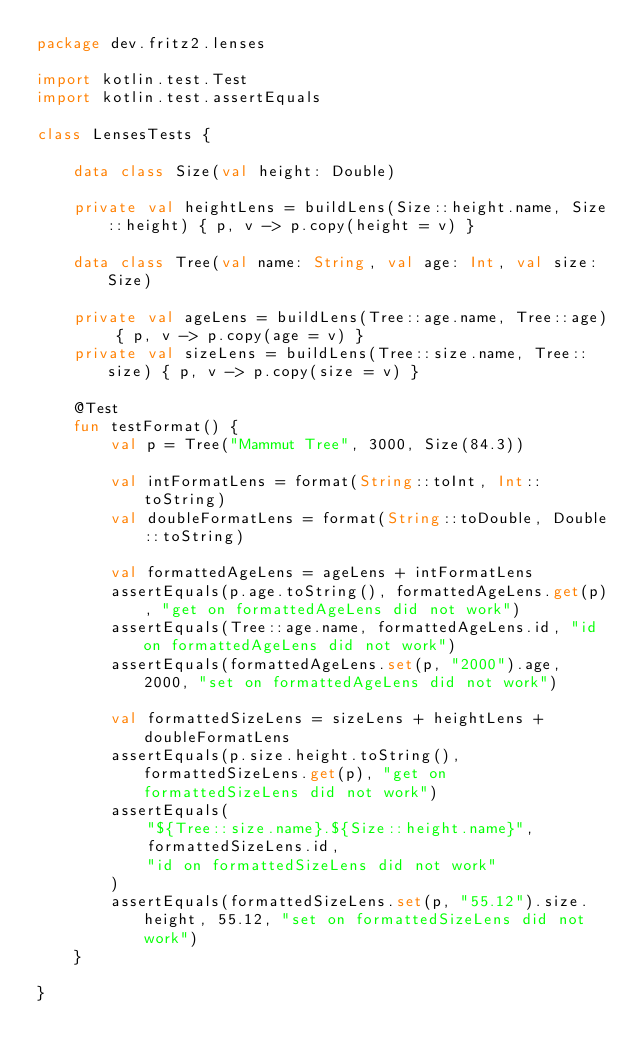Convert code to text. <code><loc_0><loc_0><loc_500><loc_500><_Kotlin_>package dev.fritz2.lenses

import kotlin.test.Test
import kotlin.test.assertEquals

class LensesTests {

    data class Size(val height: Double)

    private val heightLens = buildLens(Size::height.name, Size::height) { p, v -> p.copy(height = v) }

    data class Tree(val name: String, val age: Int, val size: Size)

    private val ageLens = buildLens(Tree::age.name, Tree::age) { p, v -> p.copy(age = v) }
    private val sizeLens = buildLens(Tree::size.name, Tree::size) { p, v -> p.copy(size = v) }

    @Test
    fun testFormat() {
        val p = Tree("Mammut Tree", 3000, Size(84.3))

        val intFormatLens = format(String::toInt, Int::toString)
        val doubleFormatLens = format(String::toDouble, Double::toString)

        val formattedAgeLens = ageLens + intFormatLens
        assertEquals(p.age.toString(), formattedAgeLens.get(p), "get on formattedAgeLens did not work")
        assertEquals(Tree::age.name, formattedAgeLens.id, "id on formattedAgeLens did not work")
        assertEquals(formattedAgeLens.set(p, "2000").age, 2000, "set on formattedAgeLens did not work")

        val formattedSizeLens = sizeLens + heightLens + doubleFormatLens
        assertEquals(p.size.height.toString(), formattedSizeLens.get(p), "get on formattedSizeLens did not work")
        assertEquals(
            "${Tree::size.name}.${Size::height.name}",
            formattedSizeLens.id,
            "id on formattedSizeLens did not work"
        )
        assertEquals(formattedSizeLens.set(p, "55.12").size.height, 55.12, "set on formattedSizeLens did not work")
    }

}</code> 